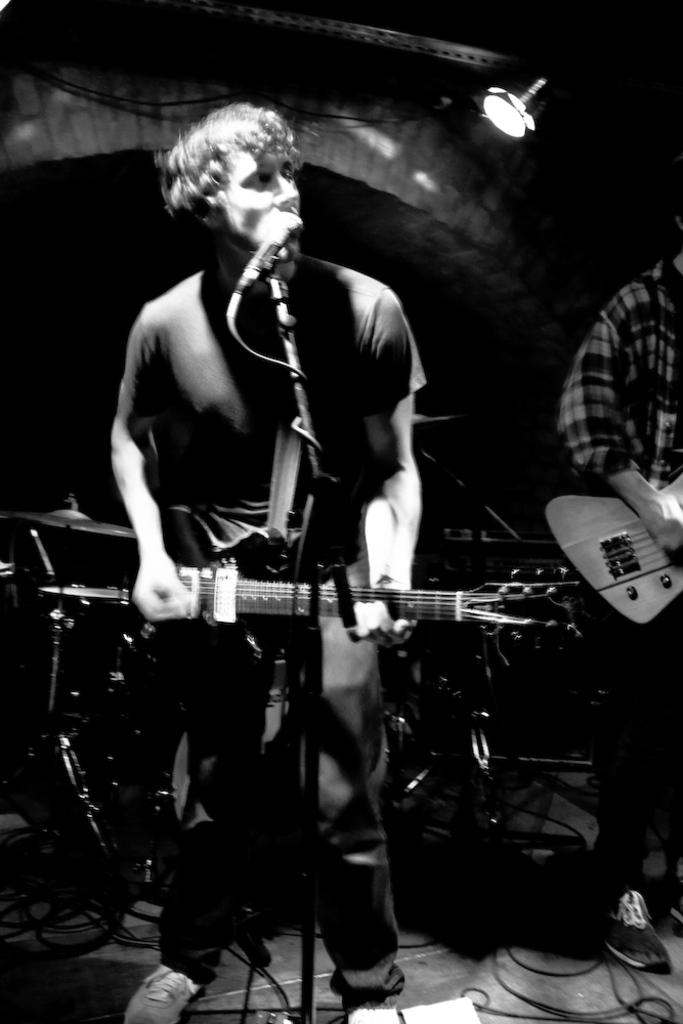What is the main subject of the image? There is a person in the image. What is the person doing in the image? The person is standing and playing a guitar. What else is the person doing while playing the guitar? The person is also singing. What type of car can be seen parked next to the person in the image? There is no car present in the image. How many words can be seen written on the person's shirt in the image? The person's shirt is not visible in the image, so it cannot be determined if any words are written on it. 